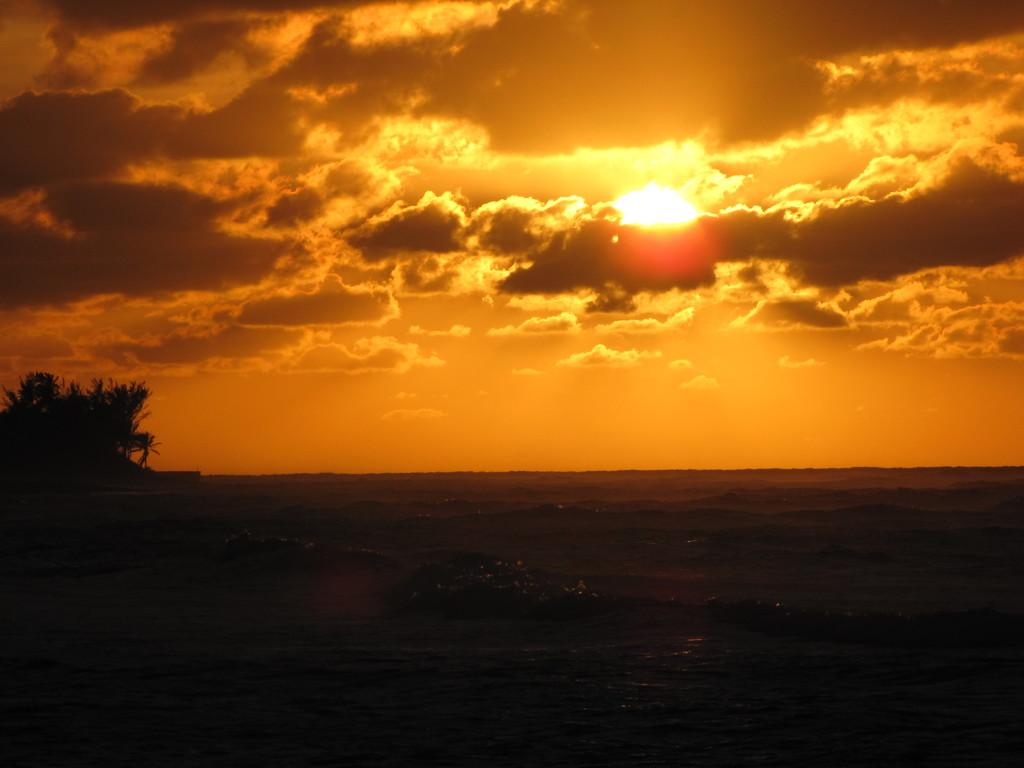What time of day is depicted in the image? The image depicts a sunset, which typically occurs in the evening. What can be seen on the left side of the image? There is a tree on the left side of the image. Can you see a snail crawling on the tree in the image? There is no snail present on the tree in the image. 